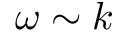<formula> <loc_0><loc_0><loc_500><loc_500>\omega \sim k</formula> 